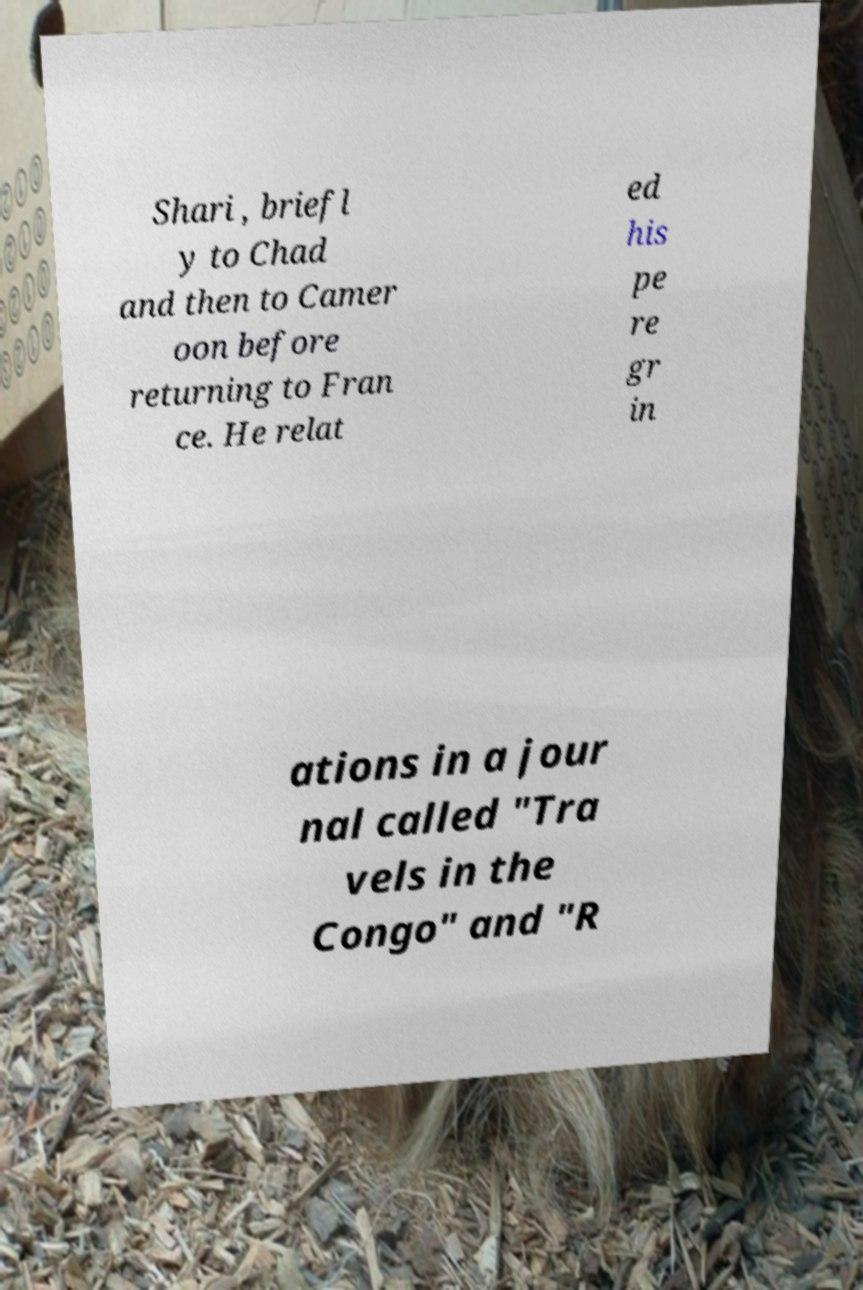What messages or text are displayed in this image? I need them in a readable, typed format. Shari , briefl y to Chad and then to Camer oon before returning to Fran ce. He relat ed his pe re gr in ations in a jour nal called "Tra vels in the Congo" and "R 